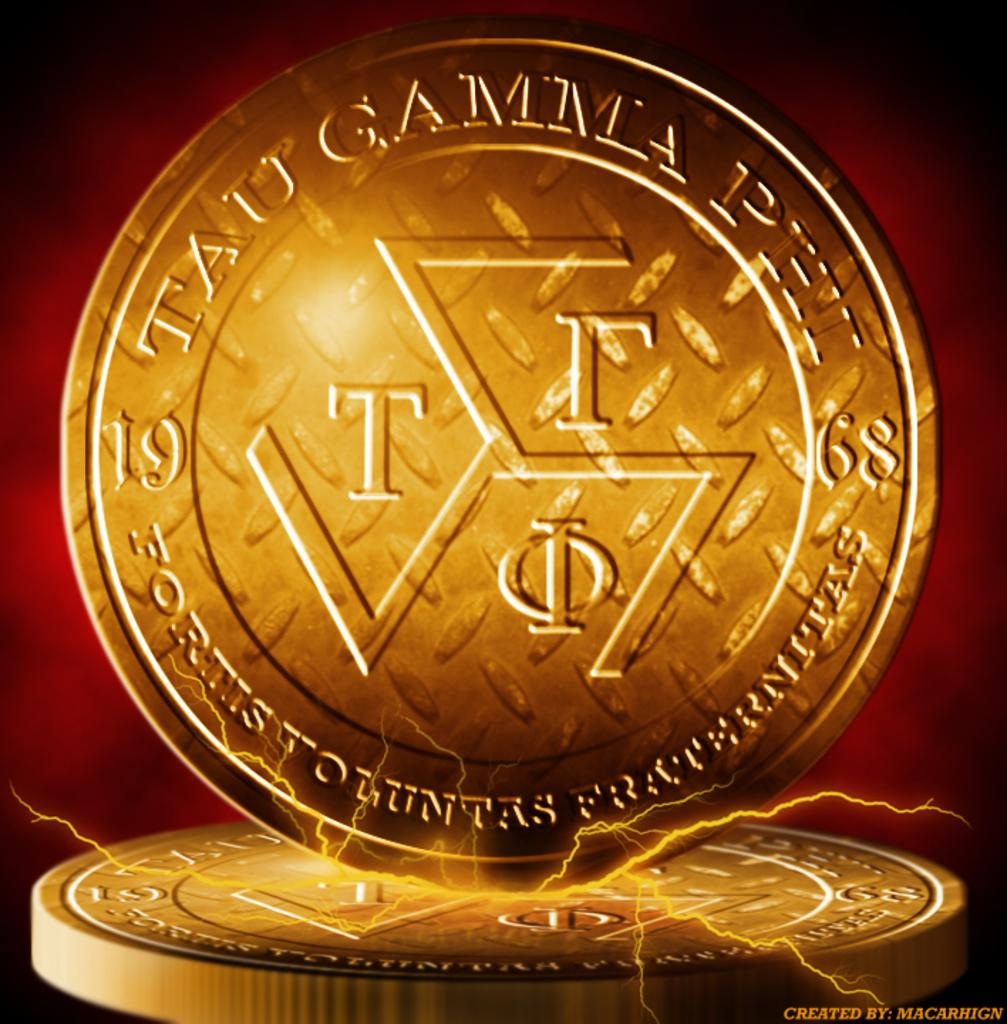<image>
Render a clear and concise summary of the photo. Gold coin saying "Tau Gamma Phi" on top of another gold coin. 